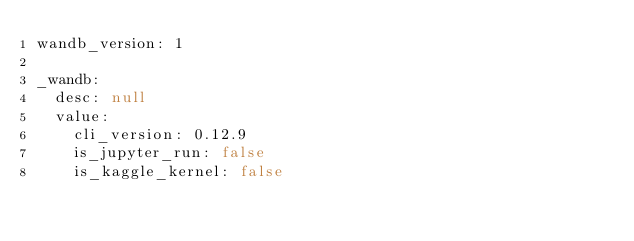<code> <loc_0><loc_0><loc_500><loc_500><_YAML_>wandb_version: 1

_wandb:
  desc: null
  value:
    cli_version: 0.12.9
    is_jupyter_run: false
    is_kaggle_kernel: false</code> 